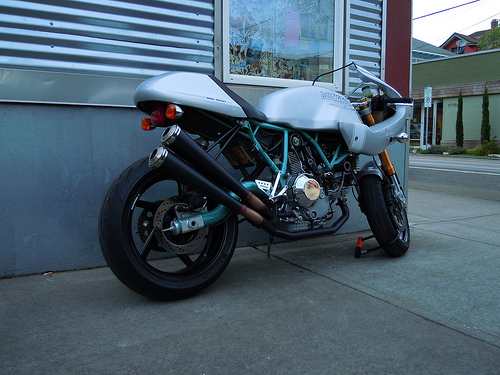<image>
Is the bike behind the building? No. The bike is not behind the building. From this viewpoint, the bike appears to be positioned elsewhere in the scene. Where is the motor bike in relation to the house? Is it in front of the house? Yes. The motor bike is positioned in front of the house, appearing closer to the camera viewpoint. 